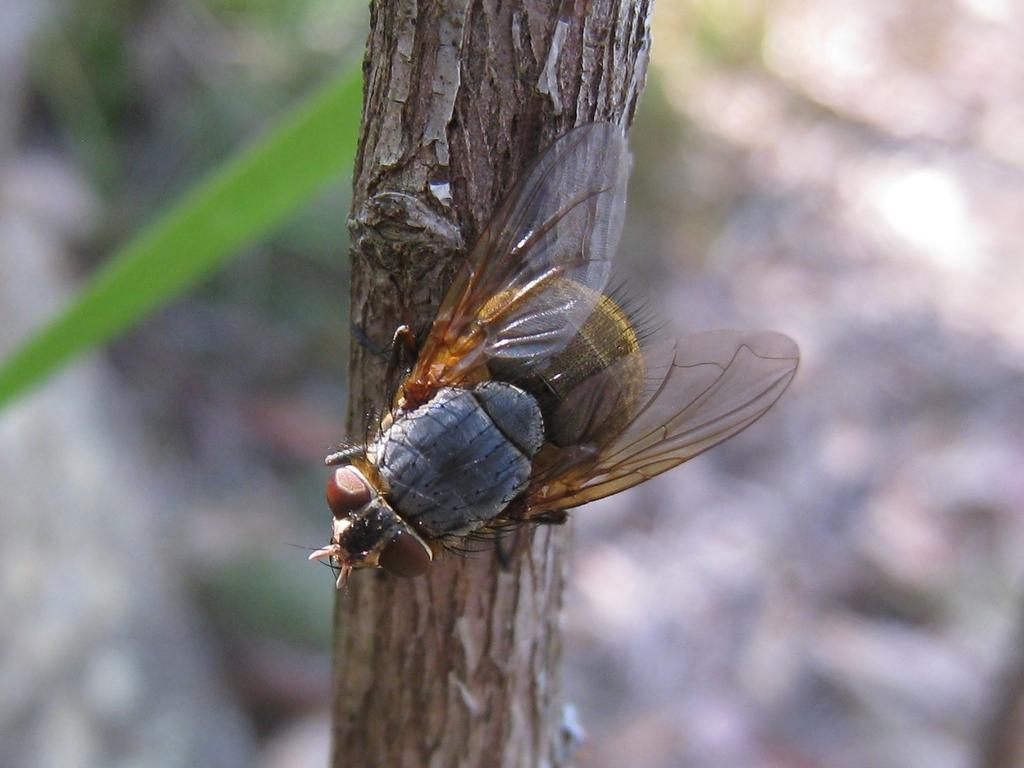What is present on the stem of the plant in the image? There is a house fly on the stem of a plant in the image. Can you describe the background of the image? The backdrop of the image is blurred. What type of circle can be seen on the turkey in the image? There is no turkey or circle present in the image; it features a house fly on the stem of a plant with a blurred backdrop. 